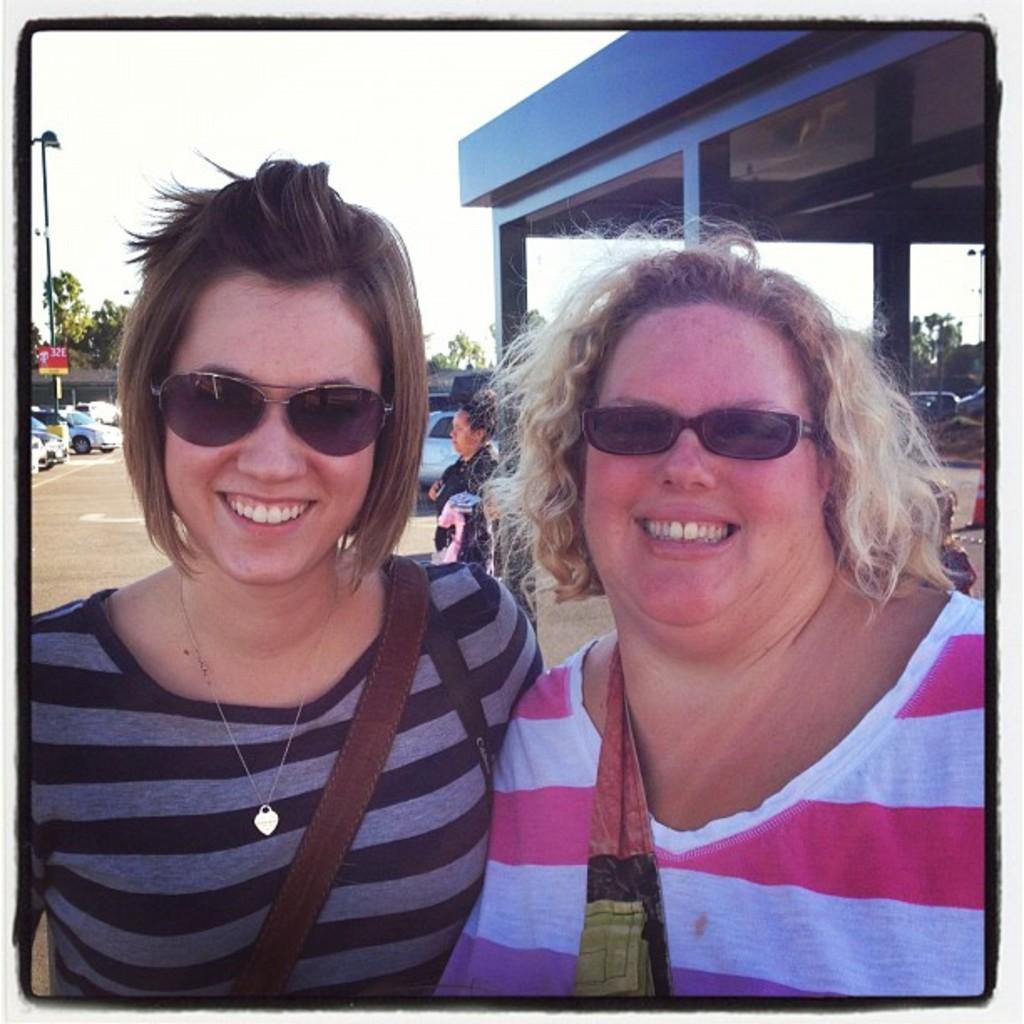Please provide a concise description of this image. In this image I can see two women and I can see both of them are wearing shades. I can also see smile on their faces. Here I can see she is wearing grey top and she is wearing white and red. In the background I can see one more person and I can see number of vehicles. I can also see a pole, a red colour board, a light, few trees and few buildings. 